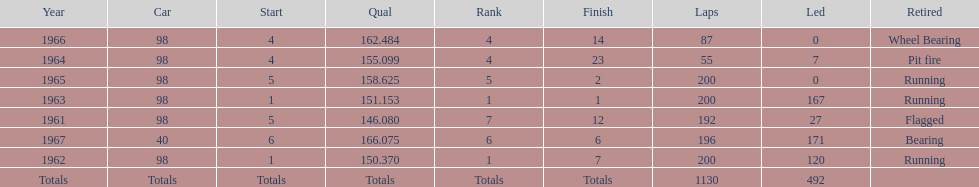Which automobile attained the top qualification? 40. 